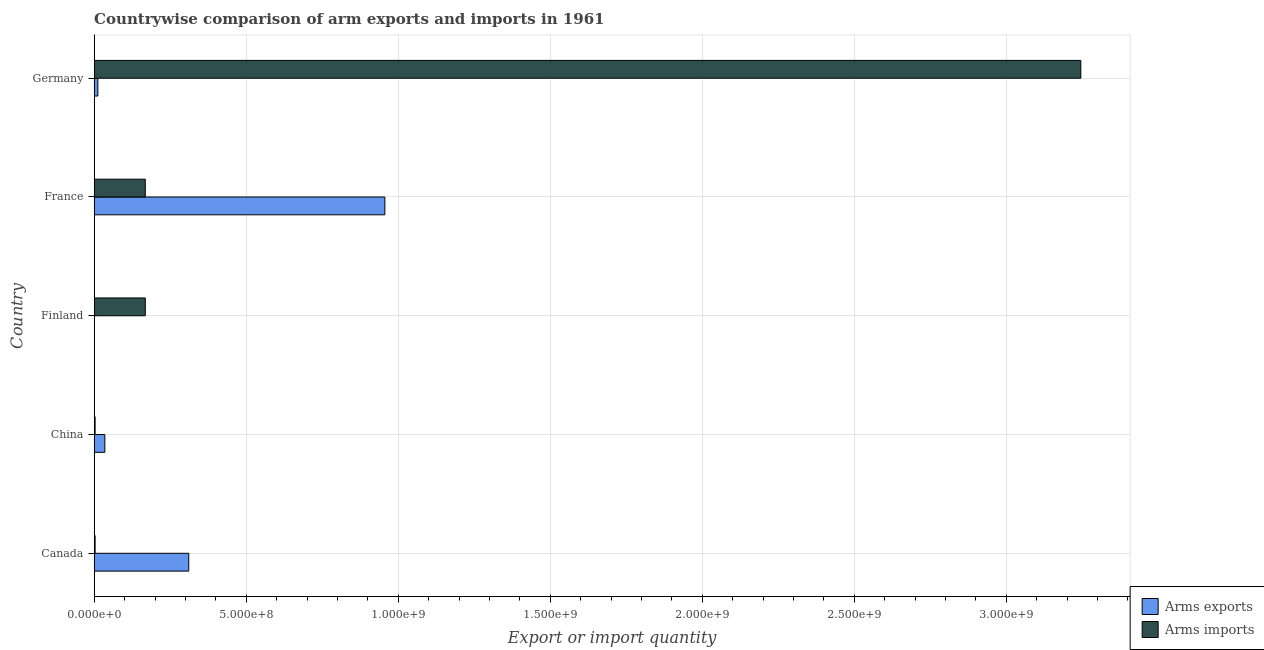How many different coloured bars are there?
Give a very brief answer. 2. How many groups of bars are there?
Offer a very short reply. 5. How many bars are there on the 4th tick from the top?
Ensure brevity in your answer.  2. How many bars are there on the 3rd tick from the bottom?
Provide a short and direct response. 2. What is the arms imports in Finland?
Your answer should be very brief. 1.68e+08. Across all countries, what is the maximum arms exports?
Offer a very short reply. 9.56e+08. Across all countries, what is the minimum arms imports?
Offer a terse response. 3.00e+06. In which country was the arms imports maximum?
Give a very brief answer. Germany. What is the total arms imports in the graph?
Offer a very short reply. 3.59e+09. What is the difference between the arms imports in Canada and that in Finland?
Provide a succinct answer. -1.65e+08. What is the difference between the arms imports in China and the arms exports in France?
Ensure brevity in your answer.  -9.53e+08. What is the average arms imports per country?
Your answer should be very brief. 7.17e+08. What is the difference between the arms exports and arms imports in Canada?
Provide a succinct answer. 3.08e+08. What is the ratio of the arms exports in Canada to that in Germany?
Provide a succinct answer. 25.92. Is the arms imports in France less than that in Germany?
Offer a terse response. Yes. Is the difference between the arms imports in France and Germany greater than the difference between the arms exports in France and Germany?
Ensure brevity in your answer.  No. What is the difference between the highest and the second highest arms imports?
Your answer should be very brief. 3.08e+09. What is the difference between the highest and the lowest arms exports?
Provide a succinct answer. 9.55e+08. In how many countries, is the arms imports greater than the average arms imports taken over all countries?
Ensure brevity in your answer.  1. What does the 2nd bar from the top in Germany represents?
Make the answer very short. Arms exports. What does the 1st bar from the bottom in France represents?
Ensure brevity in your answer.  Arms exports. Are the values on the major ticks of X-axis written in scientific E-notation?
Provide a succinct answer. Yes. What is the title of the graph?
Ensure brevity in your answer.  Countrywise comparison of arm exports and imports in 1961. What is the label or title of the X-axis?
Give a very brief answer. Export or import quantity. What is the label or title of the Y-axis?
Make the answer very short. Country. What is the Export or import quantity of Arms exports in Canada?
Offer a very short reply. 3.11e+08. What is the Export or import quantity in Arms exports in China?
Make the answer very short. 3.50e+07. What is the Export or import quantity in Arms exports in Finland?
Make the answer very short. 1.00e+06. What is the Export or import quantity in Arms imports in Finland?
Your response must be concise. 1.68e+08. What is the Export or import quantity of Arms exports in France?
Offer a terse response. 9.56e+08. What is the Export or import quantity in Arms imports in France?
Give a very brief answer. 1.68e+08. What is the Export or import quantity in Arms exports in Germany?
Give a very brief answer. 1.20e+07. What is the Export or import quantity in Arms imports in Germany?
Your answer should be very brief. 3.24e+09. Across all countries, what is the maximum Export or import quantity of Arms exports?
Give a very brief answer. 9.56e+08. Across all countries, what is the maximum Export or import quantity of Arms imports?
Give a very brief answer. 3.24e+09. Across all countries, what is the minimum Export or import quantity of Arms exports?
Your answer should be very brief. 1.00e+06. What is the total Export or import quantity in Arms exports in the graph?
Ensure brevity in your answer.  1.32e+09. What is the total Export or import quantity in Arms imports in the graph?
Your answer should be compact. 3.59e+09. What is the difference between the Export or import quantity of Arms exports in Canada and that in China?
Keep it short and to the point. 2.76e+08. What is the difference between the Export or import quantity of Arms exports in Canada and that in Finland?
Ensure brevity in your answer.  3.10e+08. What is the difference between the Export or import quantity in Arms imports in Canada and that in Finland?
Your answer should be compact. -1.65e+08. What is the difference between the Export or import quantity in Arms exports in Canada and that in France?
Give a very brief answer. -6.45e+08. What is the difference between the Export or import quantity of Arms imports in Canada and that in France?
Your answer should be compact. -1.65e+08. What is the difference between the Export or import quantity of Arms exports in Canada and that in Germany?
Offer a terse response. 2.99e+08. What is the difference between the Export or import quantity of Arms imports in Canada and that in Germany?
Make the answer very short. -3.24e+09. What is the difference between the Export or import quantity in Arms exports in China and that in Finland?
Your answer should be very brief. 3.40e+07. What is the difference between the Export or import quantity of Arms imports in China and that in Finland?
Make the answer very short. -1.65e+08. What is the difference between the Export or import quantity in Arms exports in China and that in France?
Offer a terse response. -9.21e+08. What is the difference between the Export or import quantity of Arms imports in China and that in France?
Your answer should be very brief. -1.65e+08. What is the difference between the Export or import quantity in Arms exports in China and that in Germany?
Offer a terse response. 2.30e+07. What is the difference between the Export or import quantity in Arms imports in China and that in Germany?
Provide a short and direct response. -3.24e+09. What is the difference between the Export or import quantity in Arms exports in Finland and that in France?
Make the answer very short. -9.55e+08. What is the difference between the Export or import quantity of Arms exports in Finland and that in Germany?
Offer a terse response. -1.10e+07. What is the difference between the Export or import quantity in Arms imports in Finland and that in Germany?
Your answer should be very brief. -3.08e+09. What is the difference between the Export or import quantity of Arms exports in France and that in Germany?
Give a very brief answer. 9.44e+08. What is the difference between the Export or import quantity of Arms imports in France and that in Germany?
Your response must be concise. -3.08e+09. What is the difference between the Export or import quantity of Arms exports in Canada and the Export or import quantity of Arms imports in China?
Make the answer very short. 3.08e+08. What is the difference between the Export or import quantity in Arms exports in Canada and the Export or import quantity in Arms imports in Finland?
Give a very brief answer. 1.43e+08. What is the difference between the Export or import quantity of Arms exports in Canada and the Export or import quantity of Arms imports in France?
Provide a short and direct response. 1.43e+08. What is the difference between the Export or import quantity in Arms exports in Canada and the Export or import quantity in Arms imports in Germany?
Your answer should be very brief. -2.93e+09. What is the difference between the Export or import quantity in Arms exports in China and the Export or import quantity in Arms imports in Finland?
Make the answer very short. -1.33e+08. What is the difference between the Export or import quantity of Arms exports in China and the Export or import quantity of Arms imports in France?
Your answer should be very brief. -1.33e+08. What is the difference between the Export or import quantity in Arms exports in China and the Export or import quantity in Arms imports in Germany?
Offer a terse response. -3.21e+09. What is the difference between the Export or import quantity of Arms exports in Finland and the Export or import quantity of Arms imports in France?
Keep it short and to the point. -1.67e+08. What is the difference between the Export or import quantity in Arms exports in Finland and the Export or import quantity in Arms imports in Germany?
Offer a terse response. -3.24e+09. What is the difference between the Export or import quantity in Arms exports in France and the Export or import quantity in Arms imports in Germany?
Your answer should be compact. -2.29e+09. What is the average Export or import quantity of Arms exports per country?
Your answer should be compact. 2.63e+08. What is the average Export or import quantity of Arms imports per country?
Offer a terse response. 7.17e+08. What is the difference between the Export or import quantity of Arms exports and Export or import quantity of Arms imports in Canada?
Offer a terse response. 3.08e+08. What is the difference between the Export or import quantity of Arms exports and Export or import quantity of Arms imports in China?
Give a very brief answer. 3.20e+07. What is the difference between the Export or import quantity in Arms exports and Export or import quantity in Arms imports in Finland?
Make the answer very short. -1.67e+08. What is the difference between the Export or import quantity of Arms exports and Export or import quantity of Arms imports in France?
Ensure brevity in your answer.  7.88e+08. What is the difference between the Export or import quantity in Arms exports and Export or import quantity in Arms imports in Germany?
Provide a short and direct response. -3.23e+09. What is the ratio of the Export or import quantity of Arms exports in Canada to that in China?
Give a very brief answer. 8.89. What is the ratio of the Export or import quantity of Arms exports in Canada to that in Finland?
Give a very brief answer. 311. What is the ratio of the Export or import quantity of Arms imports in Canada to that in Finland?
Your answer should be very brief. 0.02. What is the ratio of the Export or import quantity of Arms exports in Canada to that in France?
Provide a short and direct response. 0.33. What is the ratio of the Export or import quantity of Arms imports in Canada to that in France?
Your response must be concise. 0.02. What is the ratio of the Export or import quantity of Arms exports in Canada to that in Germany?
Provide a short and direct response. 25.92. What is the ratio of the Export or import quantity of Arms imports in Canada to that in Germany?
Make the answer very short. 0. What is the ratio of the Export or import quantity of Arms exports in China to that in Finland?
Offer a terse response. 35. What is the ratio of the Export or import quantity of Arms imports in China to that in Finland?
Offer a very short reply. 0.02. What is the ratio of the Export or import quantity in Arms exports in China to that in France?
Provide a short and direct response. 0.04. What is the ratio of the Export or import quantity of Arms imports in China to that in France?
Your answer should be compact. 0.02. What is the ratio of the Export or import quantity in Arms exports in China to that in Germany?
Offer a terse response. 2.92. What is the ratio of the Export or import quantity in Arms imports in China to that in Germany?
Offer a terse response. 0. What is the ratio of the Export or import quantity of Arms exports in Finland to that in France?
Keep it short and to the point. 0. What is the ratio of the Export or import quantity in Arms imports in Finland to that in France?
Ensure brevity in your answer.  1. What is the ratio of the Export or import quantity in Arms exports in Finland to that in Germany?
Make the answer very short. 0.08. What is the ratio of the Export or import quantity in Arms imports in Finland to that in Germany?
Keep it short and to the point. 0.05. What is the ratio of the Export or import quantity in Arms exports in France to that in Germany?
Provide a short and direct response. 79.67. What is the ratio of the Export or import quantity of Arms imports in France to that in Germany?
Your answer should be very brief. 0.05. What is the difference between the highest and the second highest Export or import quantity in Arms exports?
Your answer should be very brief. 6.45e+08. What is the difference between the highest and the second highest Export or import quantity in Arms imports?
Offer a very short reply. 3.08e+09. What is the difference between the highest and the lowest Export or import quantity in Arms exports?
Your answer should be very brief. 9.55e+08. What is the difference between the highest and the lowest Export or import quantity of Arms imports?
Give a very brief answer. 3.24e+09. 